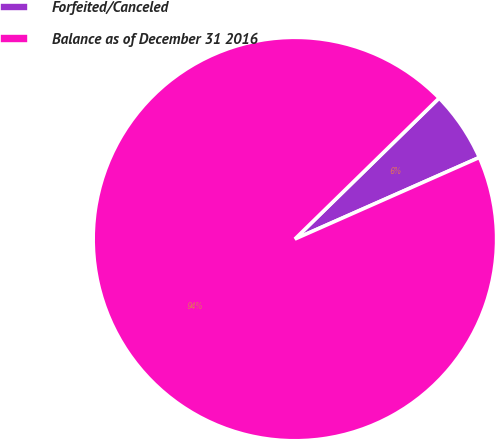Convert chart. <chart><loc_0><loc_0><loc_500><loc_500><pie_chart><fcel>Forfeited/Canceled<fcel>Balance as of December 31 2016<nl><fcel>5.69%<fcel>94.31%<nl></chart> 